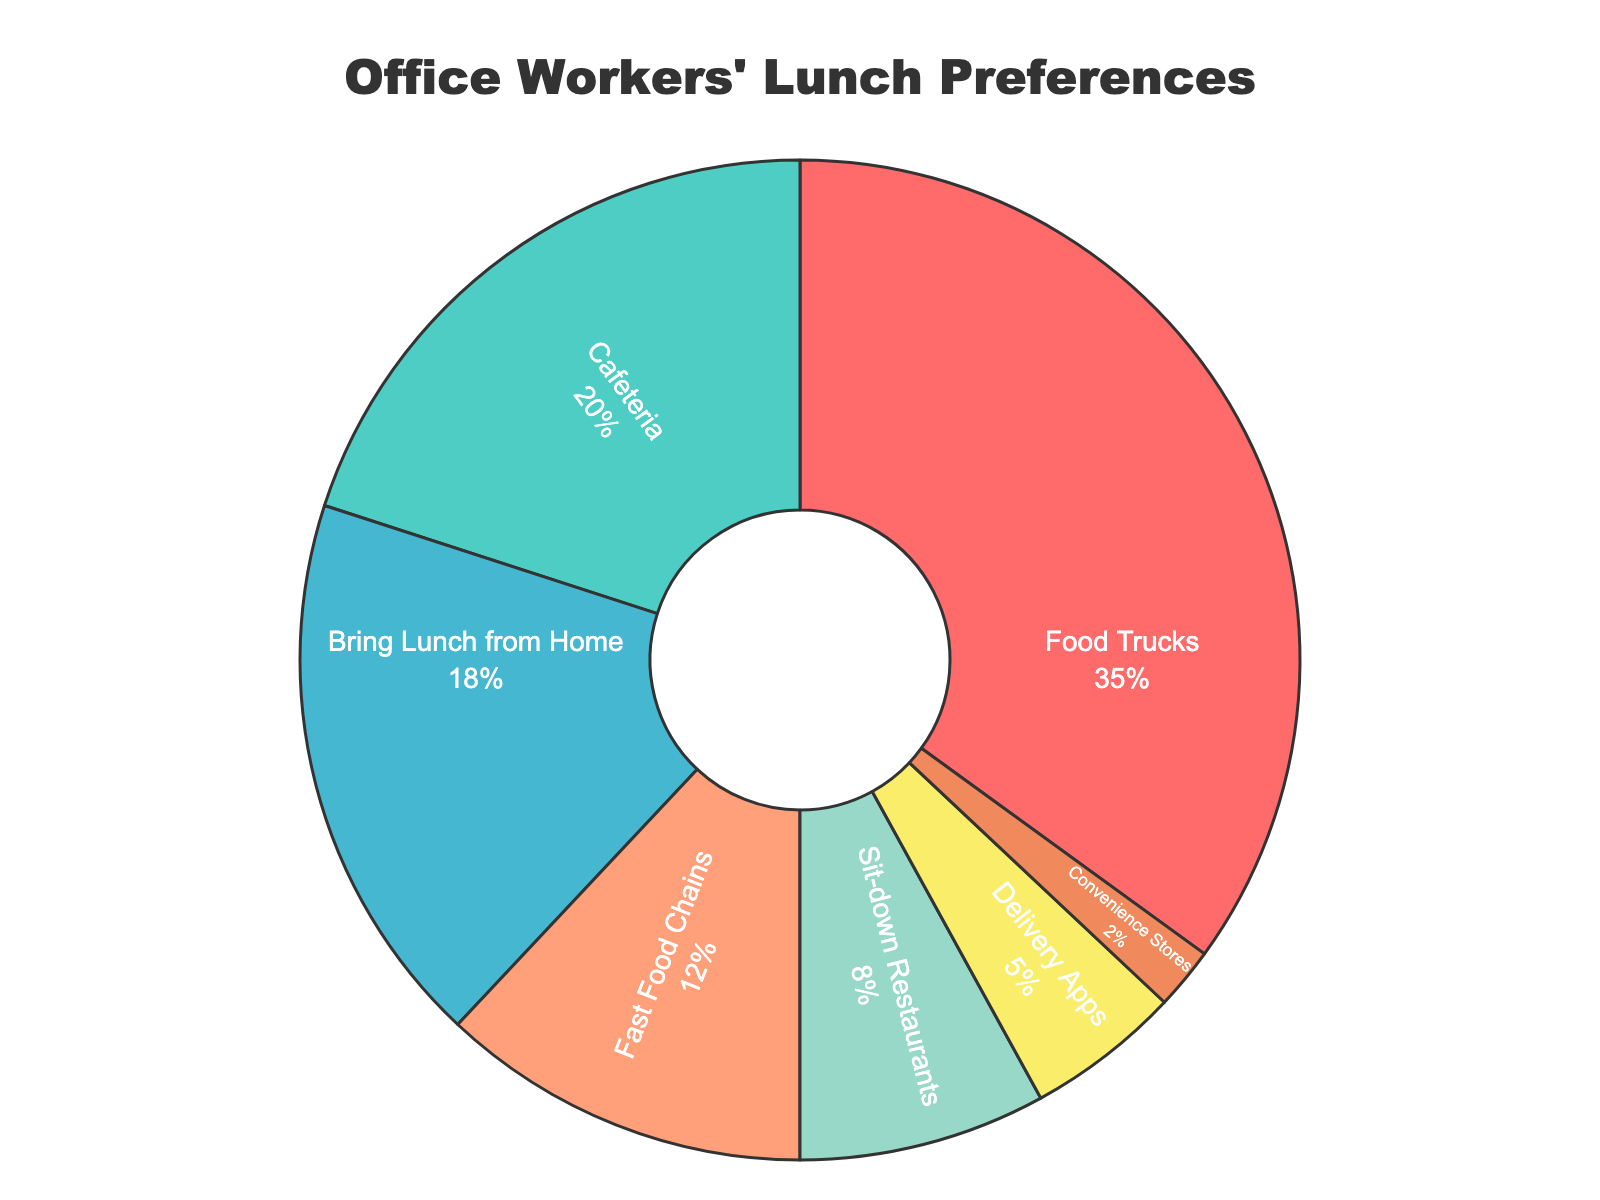What's the most popular lunch option among office workers? The largest segment of the pie chart represents the most popular lunch option.
Answer: Food Trucks What's the total percentage of office workers who do not bring lunch from home? Sum the percentages of all options except "Bring Lunch from Home": 35% + 20% + 12% + 8% + 5% + 2% = 82%
Answer: 82% How much more popular are food trucks compared to sit-down restaurants? Subtract the percentage for Sit-down Restaurants from the percentage for Food Trucks: 35% - 8% = 27%
Answer: 27% Which lunch option has the smallest percentage of office worker patronage? The smallest segment of the pie chart represents the least popular lunch option.
Answer: Convenience Stores What's the combined percentage of office workers who either bring lunch from home or go to fast food chains? Add the percentages for "Bring Lunch from Home" and "Fast Food Chains": 18% + 12% = 30%
Answer: 30% How do the percentages of office workers using delivery apps compare to those eating at the cafeteria? The percentage for Cafeteria (20%) is higher than that for Delivery Apps (5%).
Answer: Cafeteria > Delivery Apps What is the overall percentage of lunch options that involve leaving the office (food trucks, fast food chains, sit-down restaurants, and convenience stores)? Sum the percentages for these options: 35% + 12% + 8% + 2% = 57%
Answer: 57% Which lunch option uses a blue color in the pie chart? The segment colored with blue represents "Fast Food Chains."
Answer: Fast Food Chains 